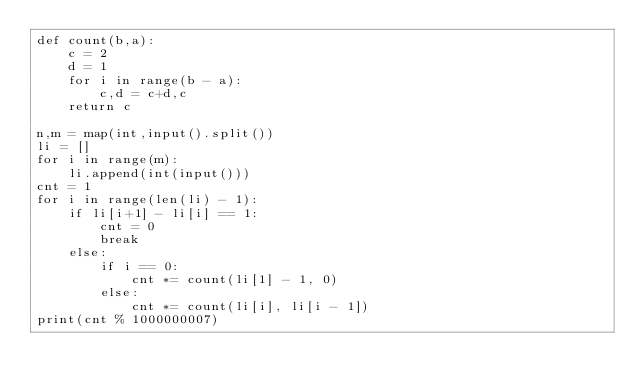Convert code to text. <code><loc_0><loc_0><loc_500><loc_500><_Python_>def count(b,a):
    c = 2
    d = 1
    for i in range(b - a):
        c,d = c+d,c
    return c
 
n,m = map(int,input().split())
li = []
for i in range(m):
    li.append(int(input()))
cnt = 1
for i in range(len(li) - 1):
    if li[i+1] - li[i] == 1:
        cnt = 0
        break
    else:
        if i == 0:
            cnt *= count(li[1] - 1, 0)
        else:
            cnt *= count(li[i], li[i - 1])
print(cnt % 1000000007)</code> 